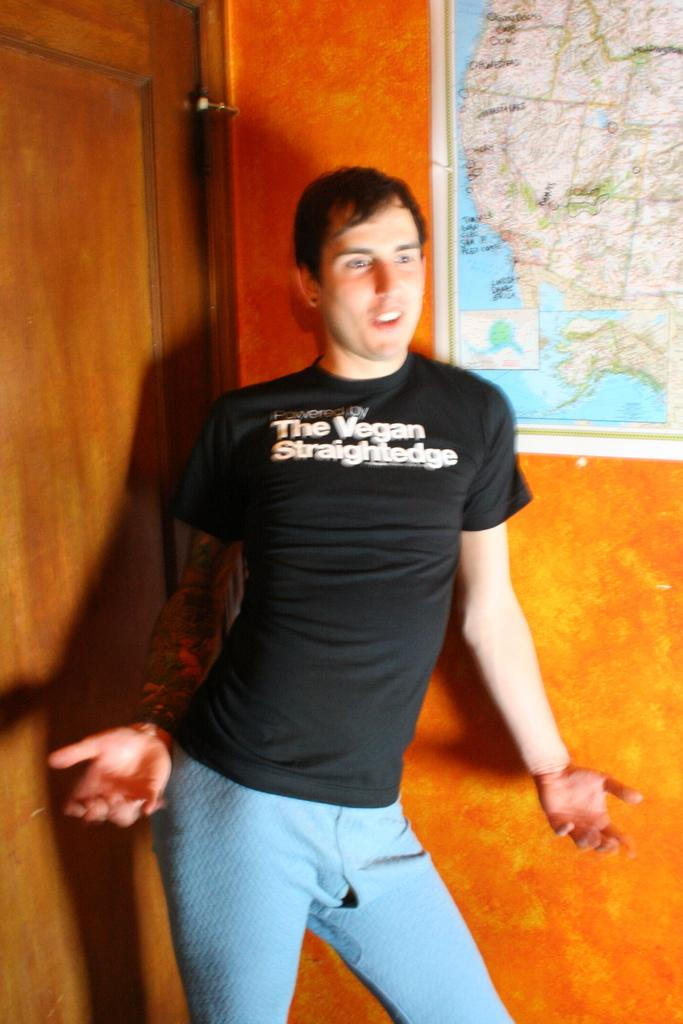<image>
Provide a brief description of the given image. A man with a full arm tattoo wearing a black shirt that reads the vegan straightedge. 